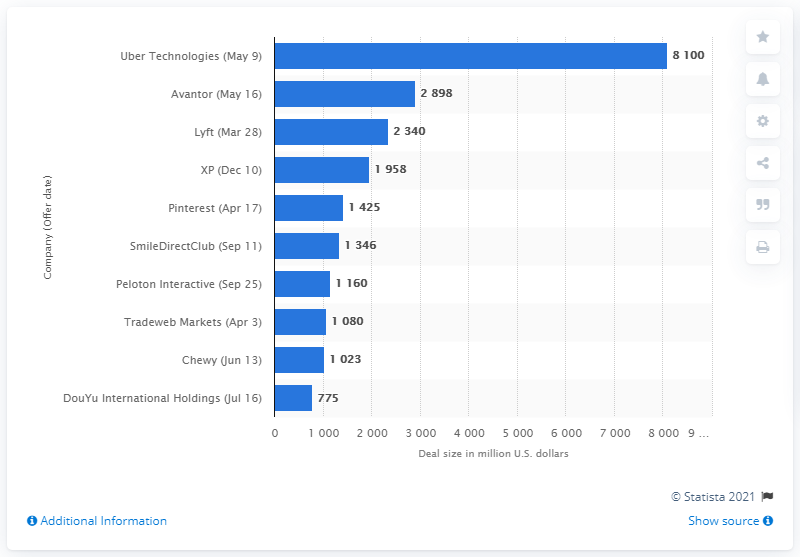Indicate a few pertinent items in this graphic. The ten largest initial public offerings (IPOs) raised a combined total of approximately 8,100 million dollars. The Initial Public Offering (IPO) raised approximately $8,100. 